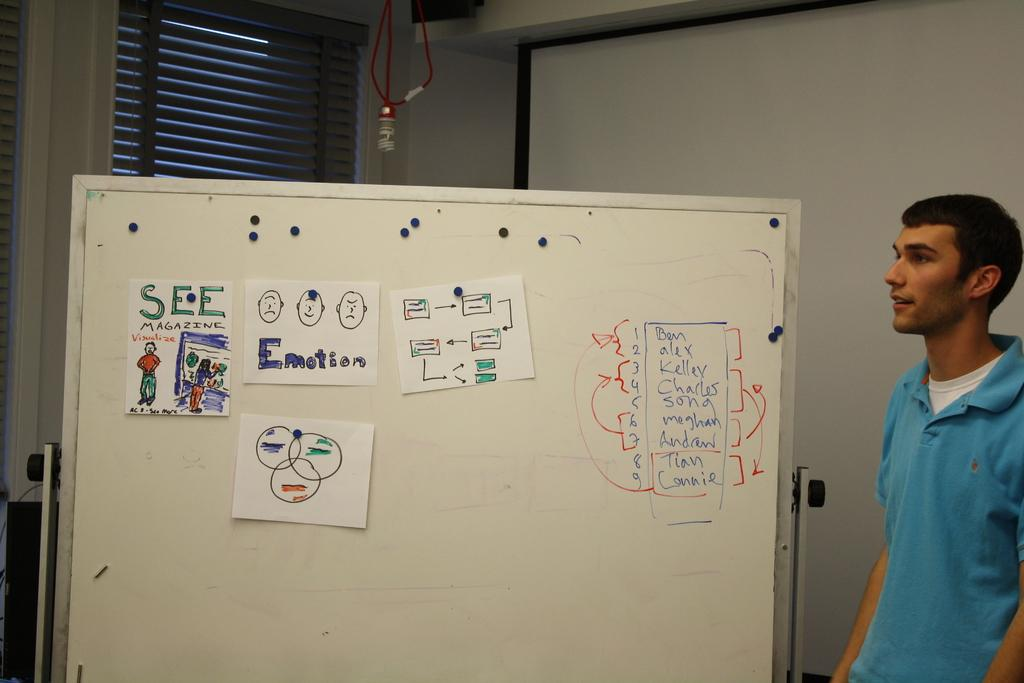<image>
Create a compact narrative representing the image presented. Man giving an explanation with a picture of "Emotion" on the board. 